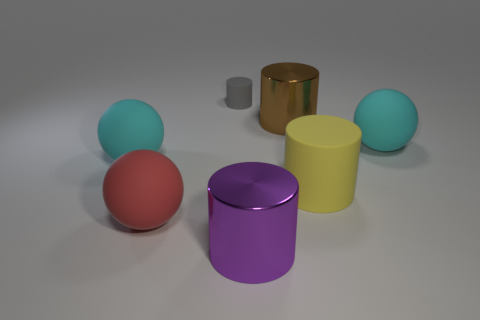How many red shiny objects are the same size as the yellow rubber thing?
Your response must be concise. 0. Is the number of big red objects right of the small rubber object less than the number of large brown cylinders?
Ensure brevity in your answer.  Yes. How many metal things are on the right side of the purple cylinder?
Give a very brief answer. 1. What size is the rubber object that is behind the cyan thing on the right side of the large shiny cylinder that is to the right of the big purple cylinder?
Your answer should be very brief. Small. Do the red rubber thing and the cyan thing to the left of the gray cylinder have the same shape?
Give a very brief answer. Yes. The gray cylinder that is the same material as the red ball is what size?
Offer a terse response. Small. Is there any other thing that has the same color as the small thing?
Offer a terse response. No. There is a brown cylinder that is in front of the cylinder that is behind the metal object behind the purple metal object; what is its material?
Offer a very short reply. Metal. How many matte objects are either spheres or large brown things?
Give a very brief answer. 3. How many objects are metal objects or shiny things that are in front of the red object?
Provide a short and direct response. 2. 